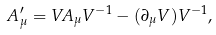<formula> <loc_0><loc_0><loc_500><loc_500>A _ { \mu } ^ { \prime } = V A _ { \mu } V ^ { - 1 } - ( \partial _ { \mu } V ) V ^ { - 1 } ,</formula> 